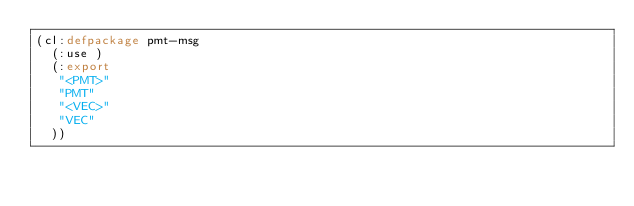Convert code to text. <code><loc_0><loc_0><loc_500><loc_500><_Lisp_>(cl:defpackage pmt-msg
  (:use )
  (:export
   "<PMT>"
   "PMT"
   "<VEC>"
   "VEC"
  ))

</code> 